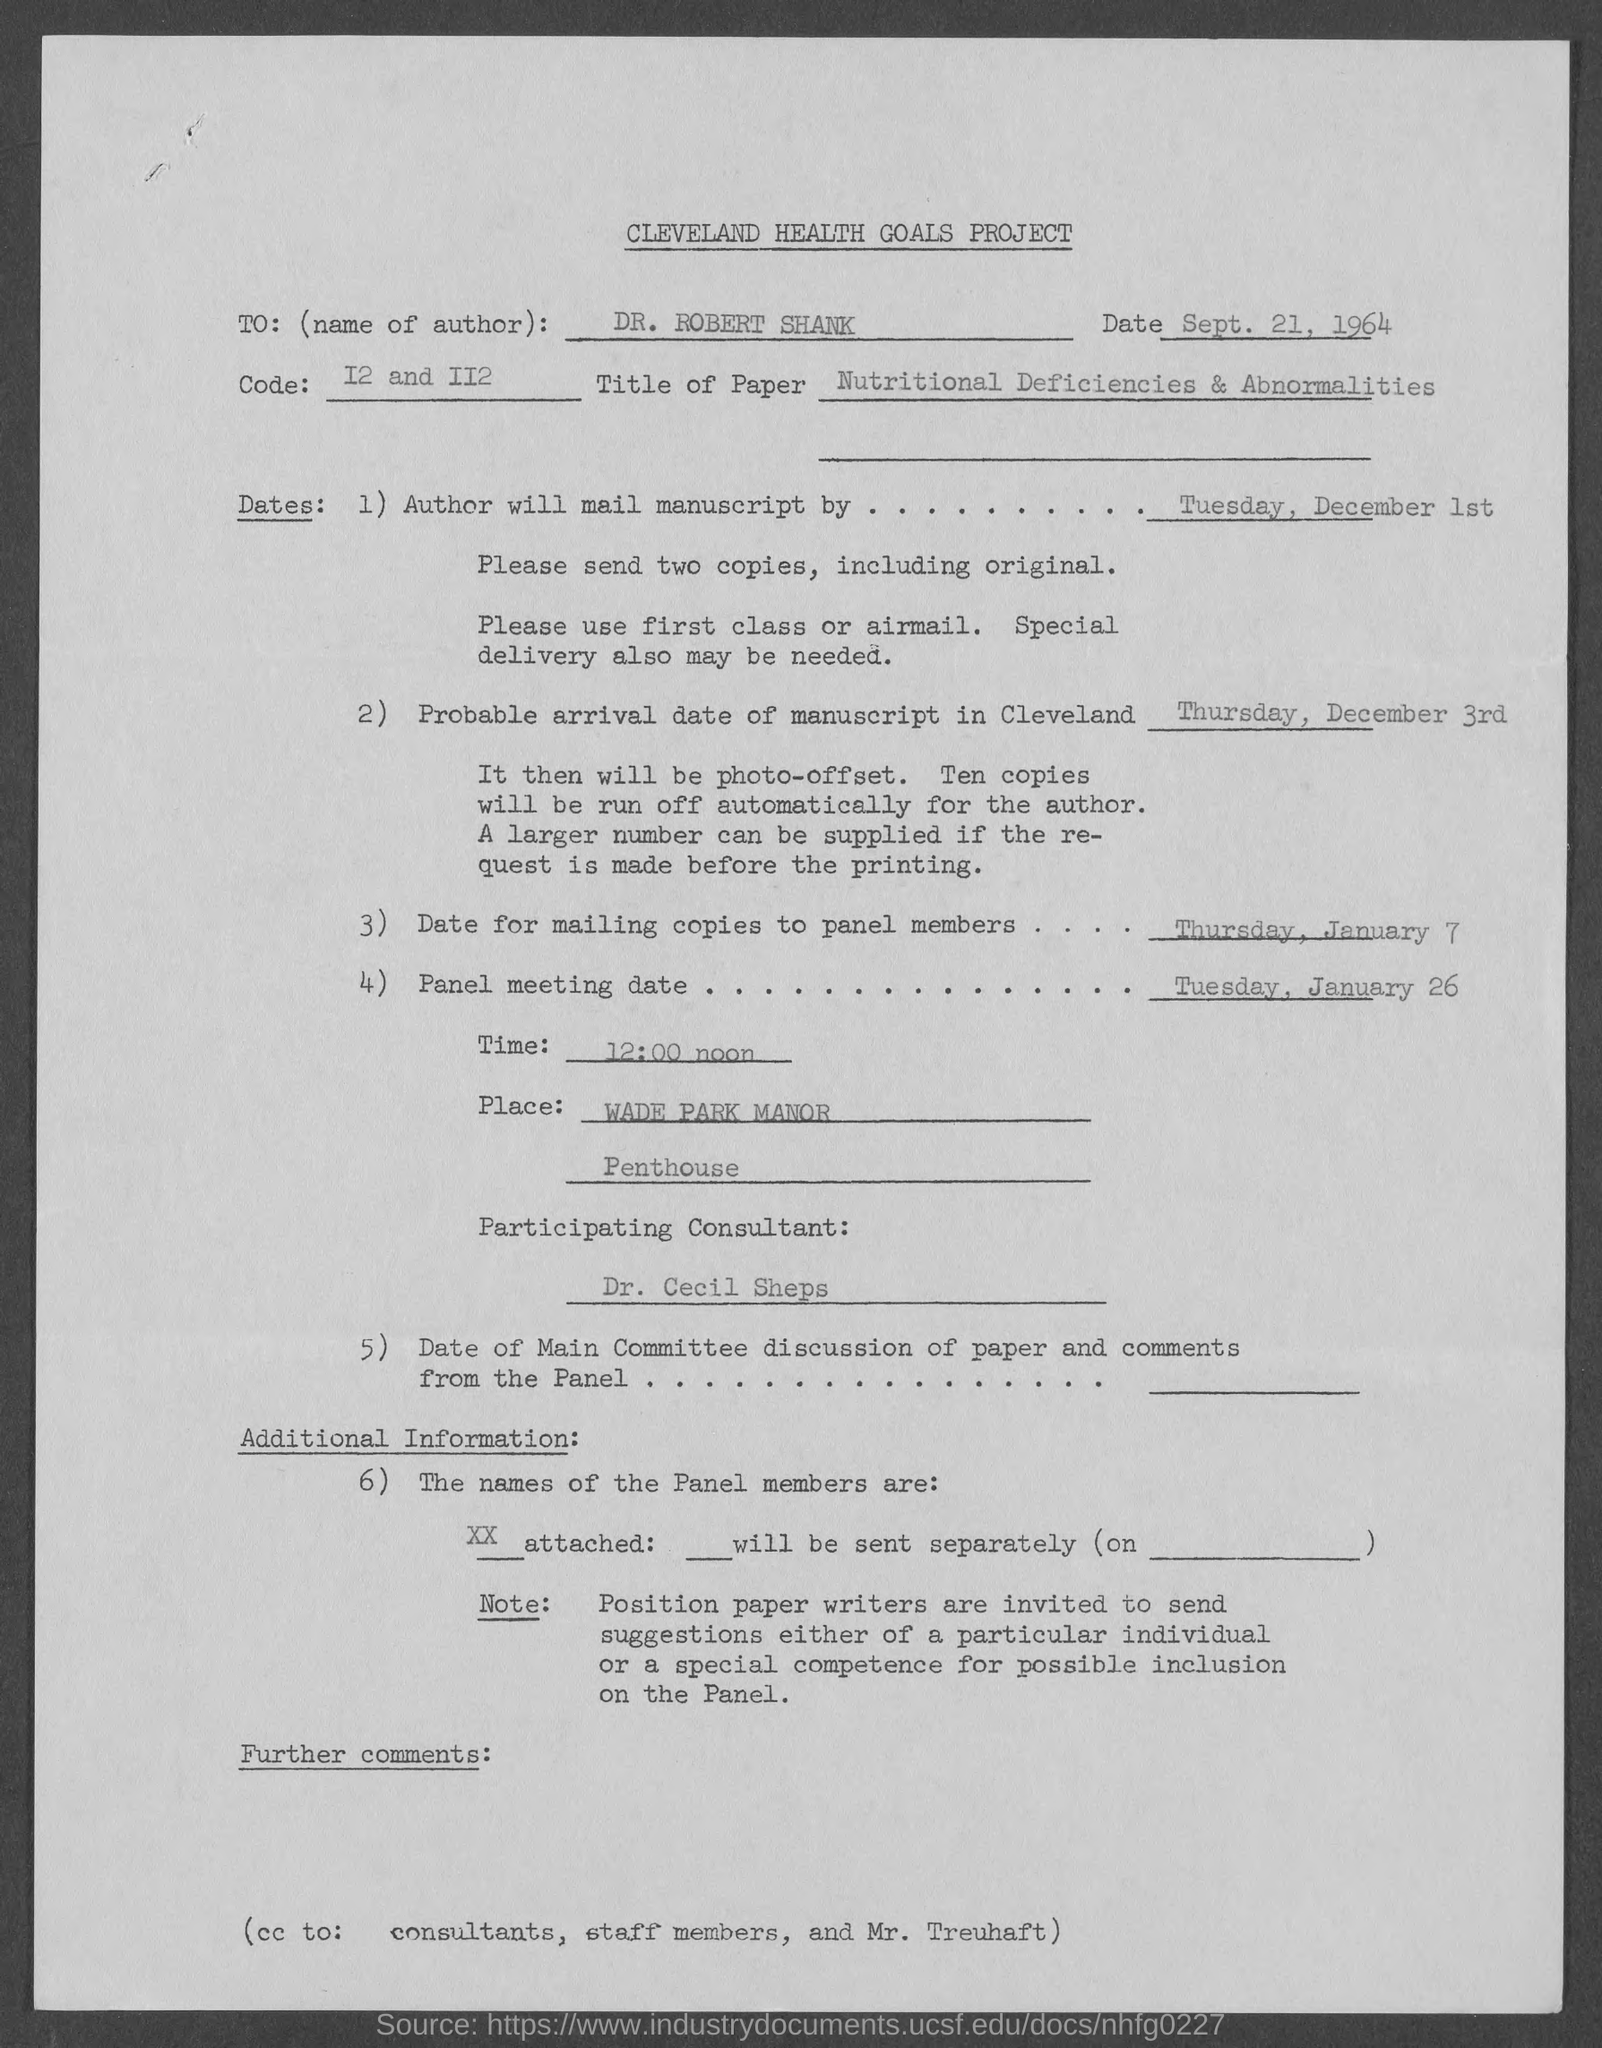Indicate a few pertinent items in this graphic. The panel meeting date, as stated in the document, is Tuesday, January 26. All individuals named in the cc of this document, including consultants, staff members, and Mr. Treuhaft, are marked. It is probable that the manuscript will arrive in Cleveland on Thursday, December 3rd. The title of this document is the CLEVELAND HEALTH GOALS PROJECT. DR. ROBERT SHANK is the author mentioned in the document. 